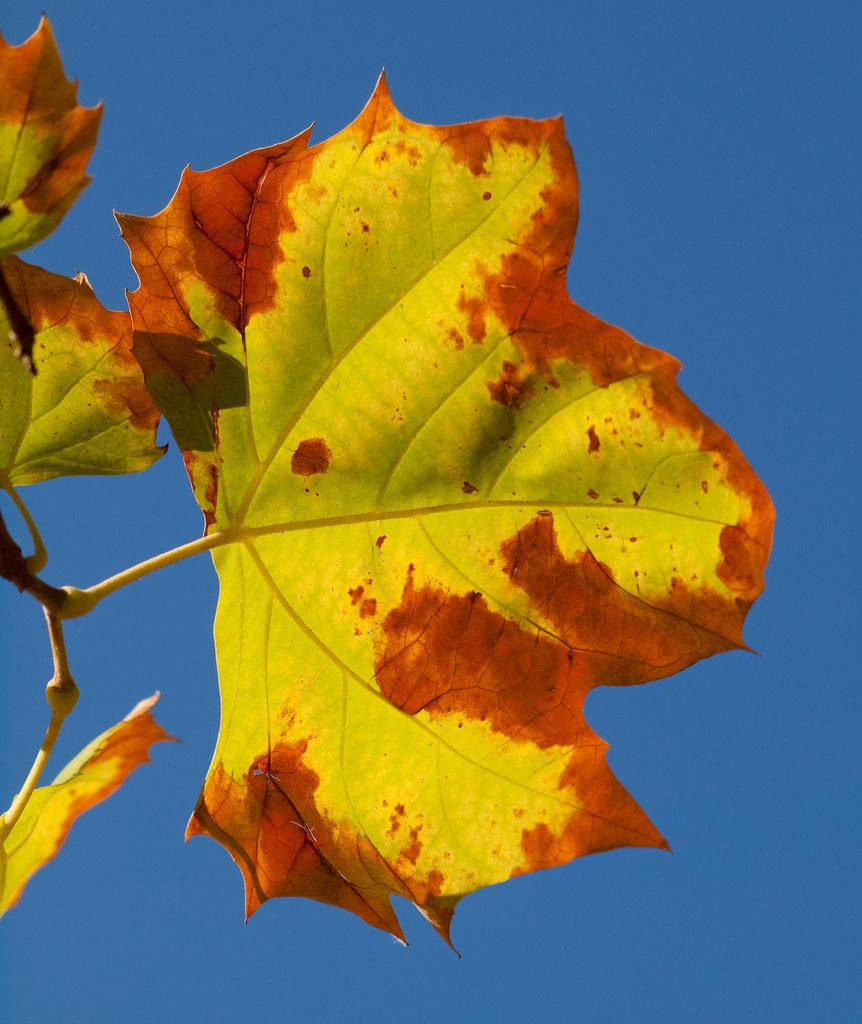What type of vegetation can be seen in the image? There are leaves in the image. What color is the sky in the image? The sky is blue in the image. How many tests are being conducted by the parent in the image? There is no parent or test present in the image; it only features leaves and a blue sky. 